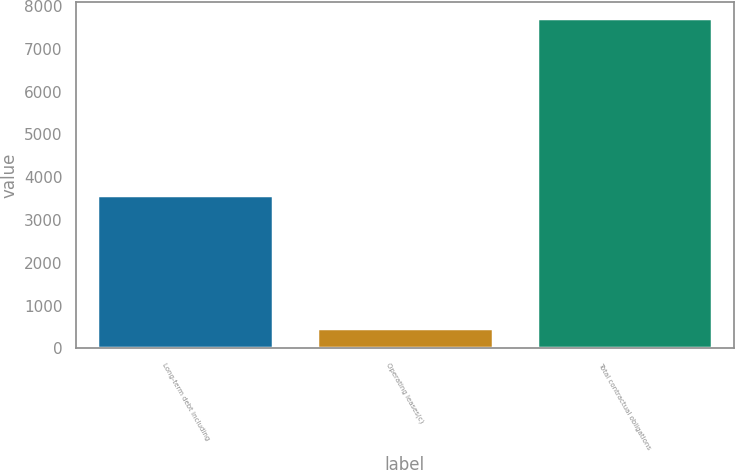Convert chart. <chart><loc_0><loc_0><loc_500><loc_500><bar_chart><fcel>Long-term debt including<fcel>Operating leases(c)<fcel>Total contractual obligations<nl><fcel>3577<fcel>467<fcel>7718<nl></chart> 